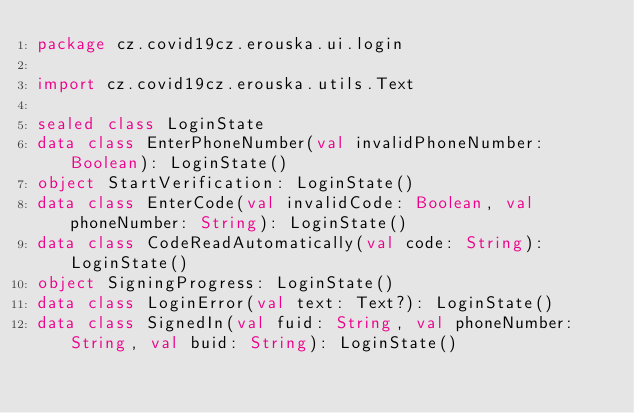Convert code to text. <code><loc_0><loc_0><loc_500><loc_500><_Kotlin_>package cz.covid19cz.erouska.ui.login

import cz.covid19cz.erouska.utils.Text

sealed class LoginState
data class EnterPhoneNumber(val invalidPhoneNumber: Boolean): LoginState()
object StartVerification: LoginState()
data class EnterCode(val invalidCode: Boolean, val phoneNumber: String): LoginState()
data class CodeReadAutomatically(val code: String): LoginState()
object SigningProgress: LoginState()
data class LoginError(val text: Text?): LoginState()
data class SignedIn(val fuid: String, val phoneNumber: String, val buid: String): LoginState()
</code> 